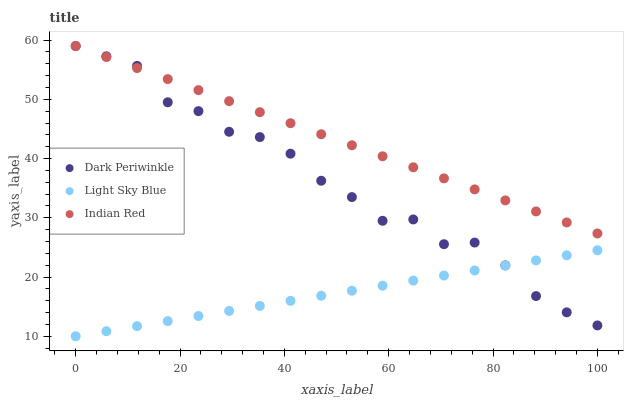Does Light Sky Blue have the minimum area under the curve?
Answer yes or no. Yes. Does Indian Red have the maximum area under the curve?
Answer yes or no. Yes. Does Dark Periwinkle have the minimum area under the curve?
Answer yes or no. No. Does Dark Periwinkle have the maximum area under the curve?
Answer yes or no. No. Is Light Sky Blue the smoothest?
Answer yes or no. Yes. Is Dark Periwinkle the roughest?
Answer yes or no. Yes. Is Indian Red the smoothest?
Answer yes or no. No. Is Indian Red the roughest?
Answer yes or no. No. Does Light Sky Blue have the lowest value?
Answer yes or no. Yes. Does Dark Periwinkle have the lowest value?
Answer yes or no. No. Does Indian Red have the highest value?
Answer yes or no. Yes. Is Light Sky Blue less than Indian Red?
Answer yes or no. Yes. Is Indian Red greater than Light Sky Blue?
Answer yes or no. Yes. Does Light Sky Blue intersect Dark Periwinkle?
Answer yes or no. Yes. Is Light Sky Blue less than Dark Periwinkle?
Answer yes or no. No. Is Light Sky Blue greater than Dark Periwinkle?
Answer yes or no. No. Does Light Sky Blue intersect Indian Red?
Answer yes or no. No. 